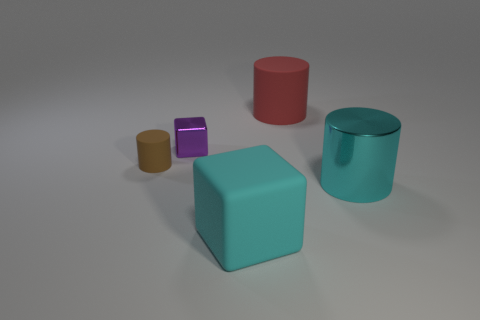What size is the cyan thing in front of the metallic object that is right of the tiny purple object?
Provide a succinct answer. Large. What is the material of the cube in front of the brown cylinder?
Provide a succinct answer. Rubber. There is a cyan object that is made of the same material as the tiny brown cylinder; what is its size?
Your answer should be very brief. Large. How many big cyan things have the same shape as the small brown matte thing?
Offer a very short reply. 1. There is a purple metallic thing; does it have the same shape as the big matte thing that is behind the tiny metallic object?
Your response must be concise. No. What is the shape of the large metal thing that is the same color as the matte cube?
Give a very brief answer. Cylinder. Are there any other large cylinders that have the same material as the cyan cylinder?
Provide a short and direct response. No. Are there any other things that have the same material as the purple block?
Provide a succinct answer. Yes. What is the material of the big cylinder in front of the small cube that is behind the cyan block?
Provide a short and direct response. Metal. How big is the matte cylinder that is behind the matte thing that is left of the large matte object to the left of the large red matte cylinder?
Your response must be concise. Large. 